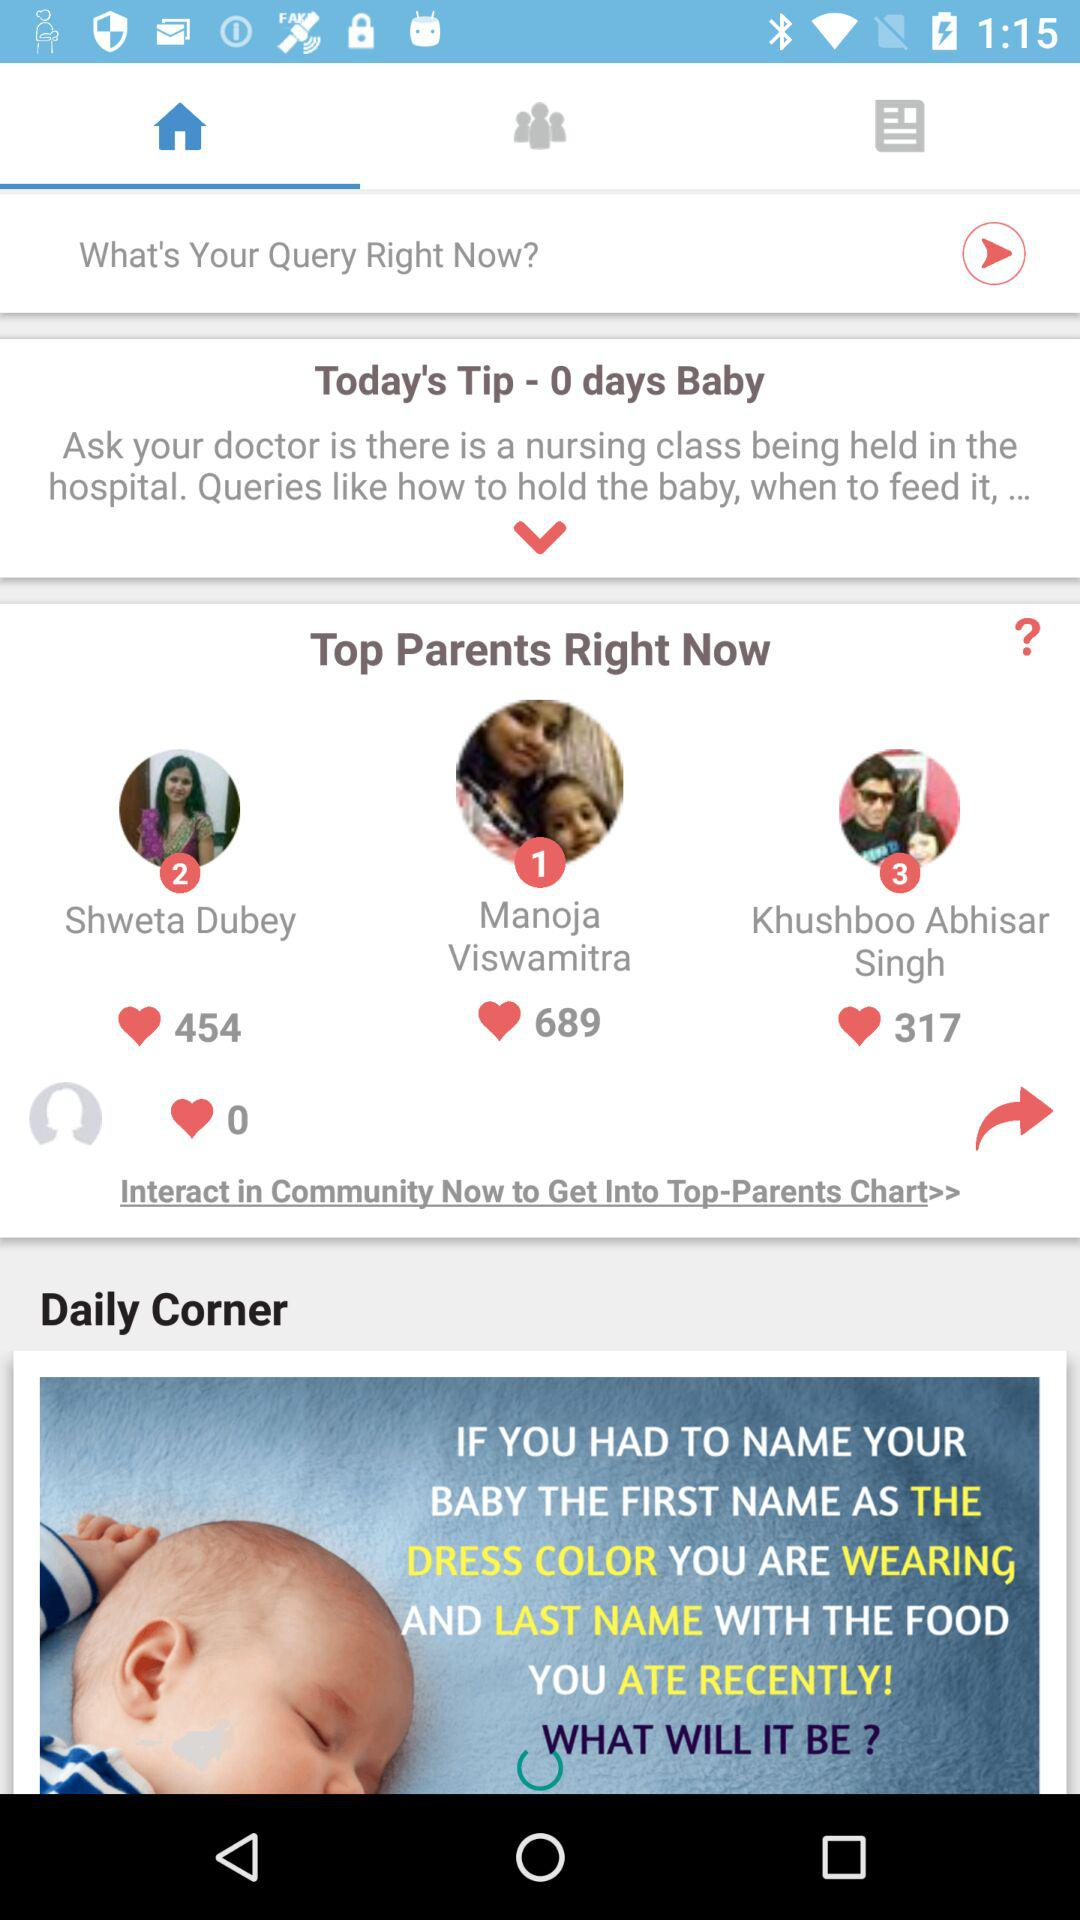How many likes did "Khushboo Abhisar Singh" get? "Khushboo Abhisar Singh" got 317 likes. 